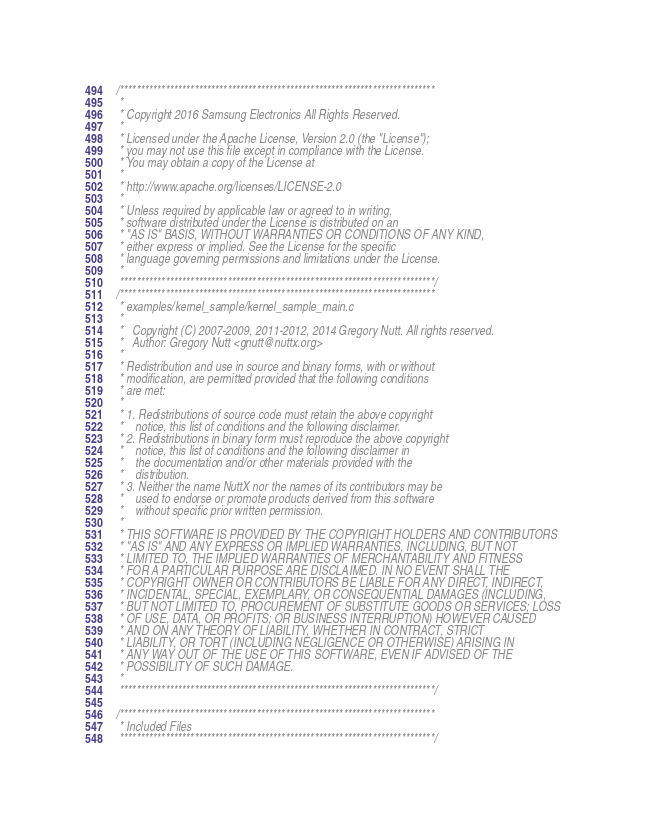<code> <loc_0><loc_0><loc_500><loc_500><_C_>/****************************************************************************
 *
 * Copyright 2016 Samsung Electronics All Rights Reserved.
 *
 * Licensed under the Apache License, Version 2.0 (the "License");
 * you may not use this file except in compliance with the License.
 * You may obtain a copy of the License at
 *
 * http://www.apache.org/licenses/LICENSE-2.0
 *
 * Unless required by applicable law or agreed to in writing,
 * software distributed under the License is distributed on an
 * "AS IS" BASIS, WITHOUT WARRANTIES OR CONDITIONS OF ANY KIND,
 * either express or implied. See the License for the specific
 * language governing permissions and limitations under the License.
 *
 ****************************************************************************/
/****************************************************************************
 * examples/kernel_sample/kernel_sample_main.c
 *
 *   Copyright (C) 2007-2009, 2011-2012, 2014 Gregory Nutt. All rights reserved.
 *   Author: Gregory Nutt <gnutt@nuttx.org>
 *
 * Redistribution and use in source and binary forms, with or without
 * modification, are permitted provided that the following conditions
 * are met:
 *
 * 1. Redistributions of source code must retain the above copyright
 *    notice, this list of conditions and the following disclaimer.
 * 2. Redistributions in binary form must reproduce the above copyright
 *    notice, this list of conditions and the following disclaimer in
 *    the documentation and/or other materials provided with the
 *    distribution.
 * 3. Neither the name NuttX nor the names of its contributors may be
 *    used to endorse or promote products derived from this software
 *    without specific prior written permission.
 *
 * THIS SOFTWARE IS PROVIDED BY THE COPYRIGHT HOLDERS AND CONTRIBUTORS
 * "AS IS" AND ANY EXPRESS OR IMPLIED WARRANTIES, INCLUDING, BUT NOT
 * LIMITED TO, THE IMPLIED WARRANTIES OF MERCHANTABILITY AND FITNESS
 * FOR A PARTICULAR PURPOSE ARE DISCLAIMED. IN NO EVENT SHALL THE
 * COPYRIGHT OWNER OR CONTRIBUTORS BE LIABLE FOR ANY DIRECT, INDIRECT,
 * INCIDENTAL, SPECIAL, EXEMPLARY, OR CONSEQUENTIAL DAMAGES (INCLUDING,
 * BUT NOT LIMITED TO, PROCUREMENT OF SUBSTITUTE GOODS OR SERVICES; LOSS
 * OF USE, DATA, OR PROFITS; OR BUSINESS INTERRUPTION) HOWEVER CAUSED
 * AND ON ANY THEORY OF LIABILITY, WHETHER IN CONTRACT, STRICT
 * LIABILITY, OR TORT (INCLUDING NEGLIGENCE OR OTHERWISE) ARISING IN
 * ANY WAY OUT OF THE USE OF THIS SOFTWARE, EVEN IF ADVISED OF THE
 * POSSIBILITY OF SUCH DAMAGE.
 *
 ****************************************************************************/

/****************************************************************************
 * Included Files
 ****************************************************************************/
</code> 